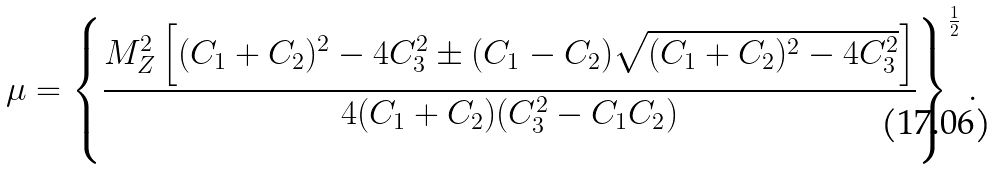Convert formula to latex. <formula><loc_0><loc_0><loc_500><loc_500>\mu = \left \{ \frac { M _ { Z } ^ { 2 } \left [ ( C _ { 1 } + C _ { 2 } ) ^ { 2 } - 4 C _ { 3 } ^ { 2 } \pm ( C _ { 1 } - C _ { 2 } ) \sqrt { ( C _ { 1 } + C _ { 2 } ) ^ { 2 } - 4 C _ { 3 } ^ { 2 } } \right ] } { 4 ( C _ { 1 } + C _ { 2 } ) ( C _ { 3 } ^ { 2 } - C _ { 1 } C _ { 2 } ) } \right \} ^ { \frac { 1 } { 2 } } .</formula> 